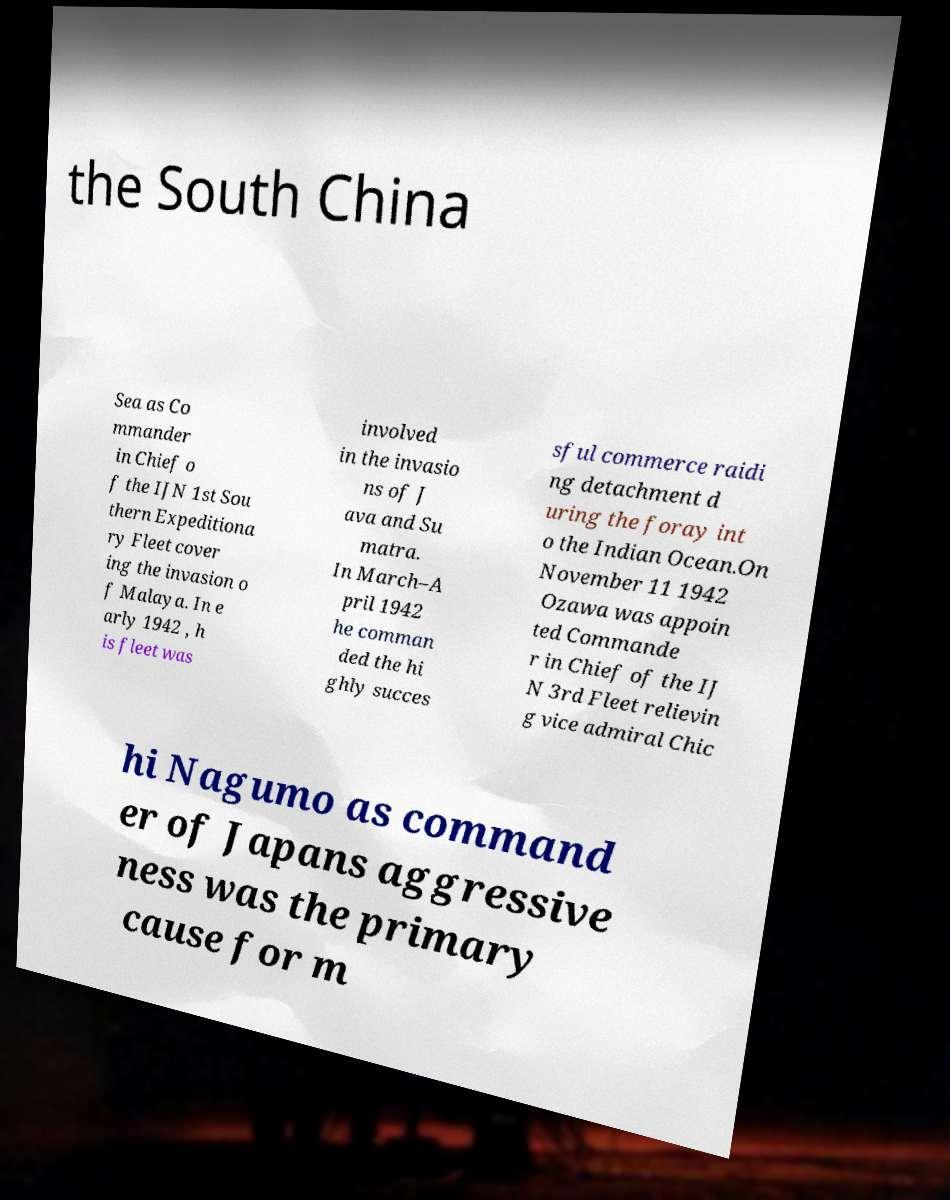What messages or text are displayed in this image? I need them in a readable, typed format. the South China Sea as Co mmander in Chief o f the IJN 1st Sou thern Expeditiona ry Fleet cover ing the invasion o f Malaya. In e arly 1942 , h is fleet was involved in the invasio ns of J ava and Su matra. In March–A pril 1942 he comman ded the hi ghly succes sful commerce raidi ng detachment d uring the foray int o the Indian Ocean.On November 11 1942 Ozawa was appoin ted Commande r in Chief of the IJ N 3rd Fleet relievin g vice admiral Chic hi Nagumo as command er of Japans aggressive ness was the primary cause for m 